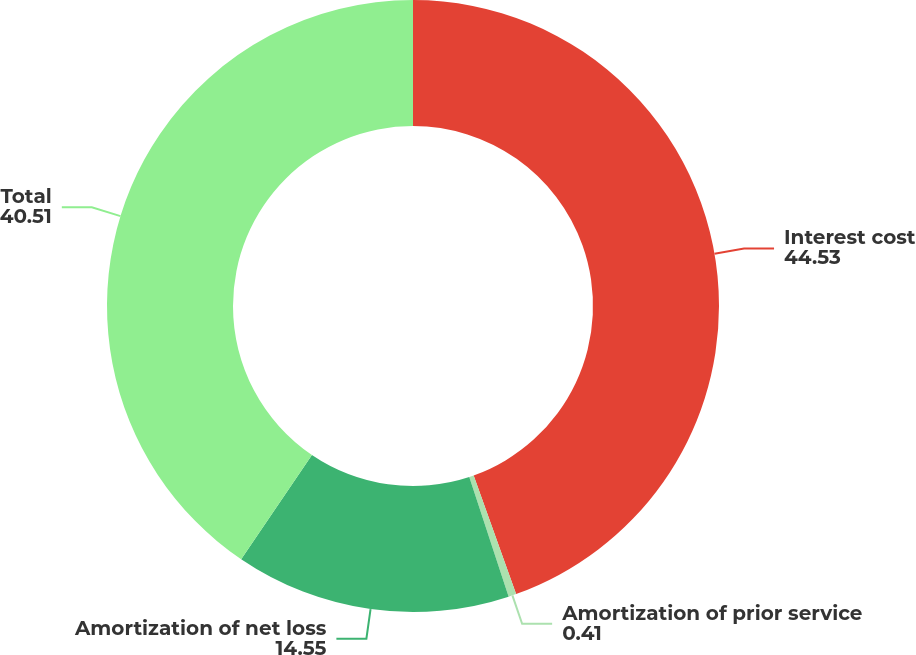<chart> <loc_0><loc_0><loc_500><loc_500><pie_chart><fcel>Interest cost<fcel>Amortization of prior service<fcel>Amortization of net loss<fcel>Total<nl><fcel>44.53%<fcel>0.41%<fcel>14.55%<fcel>40.51%<nl></chart> 